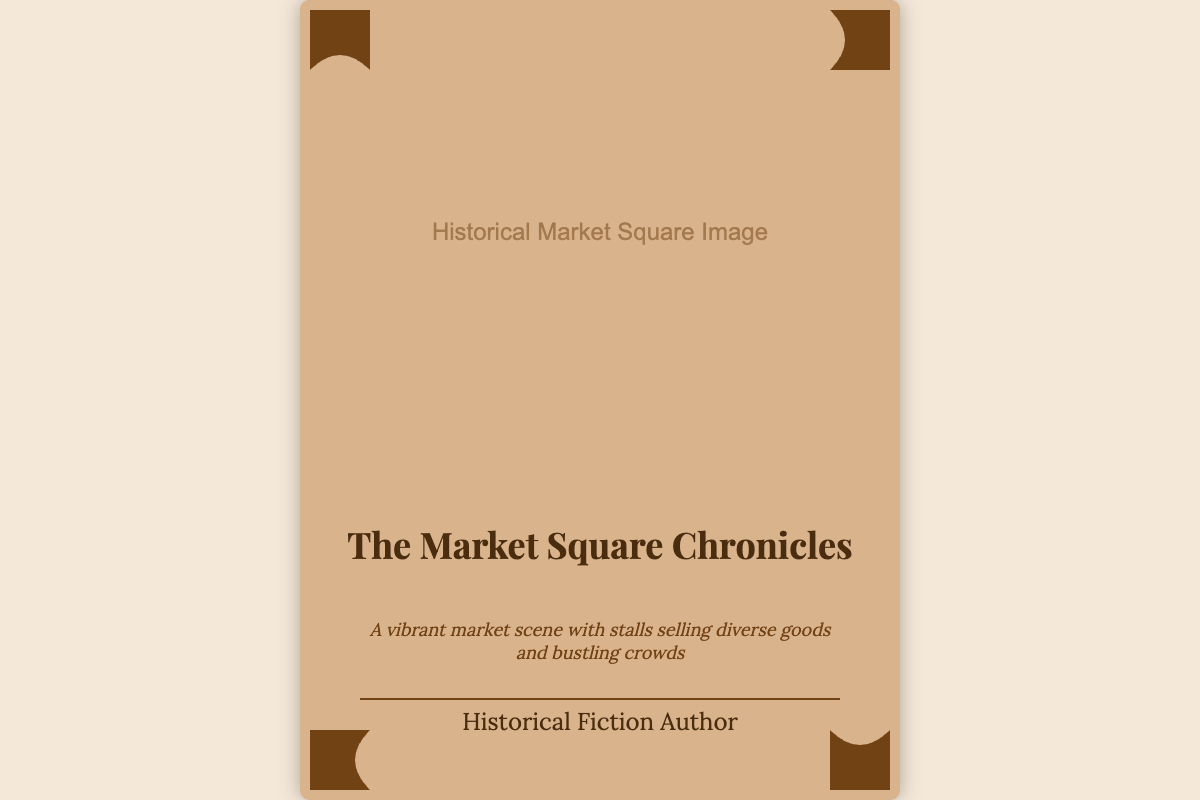What is the title of the book? The title of the book can be found prominently displayed on the cover.
Answer: The Market Square Chronicles What does the subtitle describe? The subtitle provides a brief overview of the book's content related to the market scene.
Answer: A vibrant market scene with stalls selling diverse goods and bustling crowds Which color is the dominant background of the book cover? The background color of the book cover is specified in the design details.
Answer: #d9b38c What is the author's designation? The author's designation is indicated at the bottom of the book cover.
Answer: Historical Fiction Author How many corner ornaments are present on the cover? The number of corner ornaments can be counted based on their placement in the corners.
Answer: Four What visual elements enhance the market scene? The visual elements that convey vibrancy are implied in the description of the subtitle.
Answer: Stalls and bustling crowds What is the font style used for the book title? The font style for the book title is mentioned in the design specifications.
Answer: Playfair Display Where is the book title positioned on the cover? The position of the book title is specified as being placed towards the center.
Answer: Center What element visually separates the title from the author's name? The element that separates the title from the author's name is described in the layout details.
Answer: Decorative element 